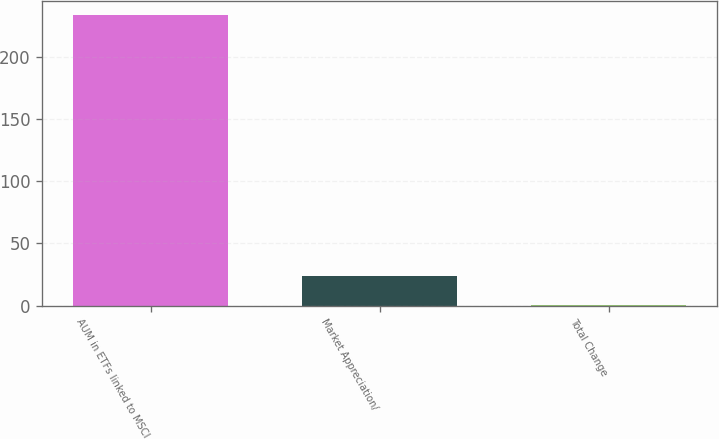<chart> <loc_0><loc_0><loc_500><loc_500><bar_chart><fcel>AUM in ETFs linked to MSCI<fcel>Market Appreciation/<fcel>Total Change<nl><fcel>233.5<fcel>23.62<fcel>0.3<nl></chart> 